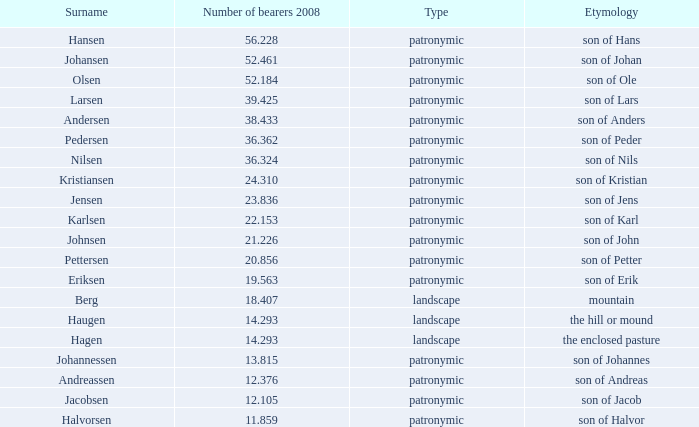What is Highest Number of Bearers 2008, when Surname is Jacobsen? 12.105. 